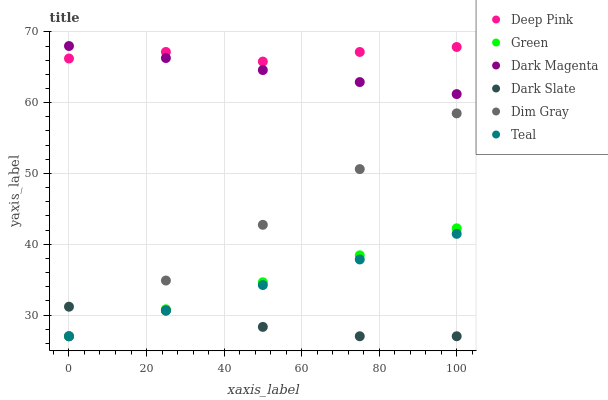Does Dark Slate have the minimum area under the curve?
Answer yes or no. Yes. Does Deep Pink have the maximum area under the curve?
Answer yes or no. Yes. Does Dark Magenta have the minimum area under the curve?
Answer yes or no. No. Does Dark Magenta have the maximum area under the curve?
Answer yes or no. No. Is Dim Gray the smoothest?
Answer yes or no. Yes. Is Deep Pink the roughest?
Answer yes or no. Yes. Is Dark Magenta the smoothest?
Answer yes or no. No. Is Dark Magenta the roughest?
Answer yes or no. No. Does Dim Gray have the lowest value?
Answer yes or no. Yes. Does Dark Magenta have the lowest value?
Answer yes or no. No. Does Dark Magenta have the highest value?
Answer yes or no. Yes. Does Dark Slate have the highest value?
Answer yes or no. No. Is Dim Gray less than Deep Pink?
Answer yes or no. Yes. Is Dark Magenta greater than Dark Slate?
Answer yes or no. Yes. Does Deep Pink intersect Dark Magenta?
Answer yes or no. Yes. Is Deep Pink less than Dark Magenta?
Answer yes or no. No. Is Deep Pink greater than Dark Magenta?
Answer yes or no. No. Does Dim Gray intersect Deep Pink?
Answer yes or no. No. 